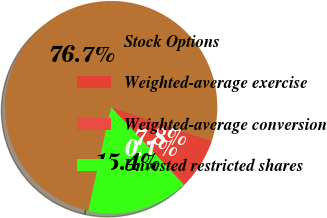Convert chart. <chart><loc_0><loc_0><loc_500><loc_500><pie_chart><fcel>Stock Options<fcel>Weighted-average exercise<fcel>Weighted-average conversion<fcel>Unvested restricted shares<nl><fcel>76.72%<fcel>7.76%<fcel>0.1%<fcel>15.42%<nl></chart> 